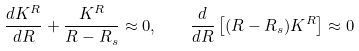<formula> <loc_0><loc_0><loc_500><loc_500>\frac { d K ^ { R } } { d R } + \frac { K ^ { R } } { R - R _ { s } } \approx 0 , \quad \frac { d } { d R } \left [ ( R - R _ { s } ) K ^ { R } \right ] \approx 0</formula> 